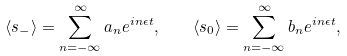<formula> <loc_0><loc_0><loc_500><loc_500>\langle s _ { - } \rangle = \sum _ { n = - \infty } ^ { \infty } a _ { n } e ^ { i n \epsilon t } , \quad \langle s _ { 0 } \rangle = \sum _ { n = - \infty } ^ { \infty } b _ { n } e ^ { i n \epsilon t } ,</formula> 